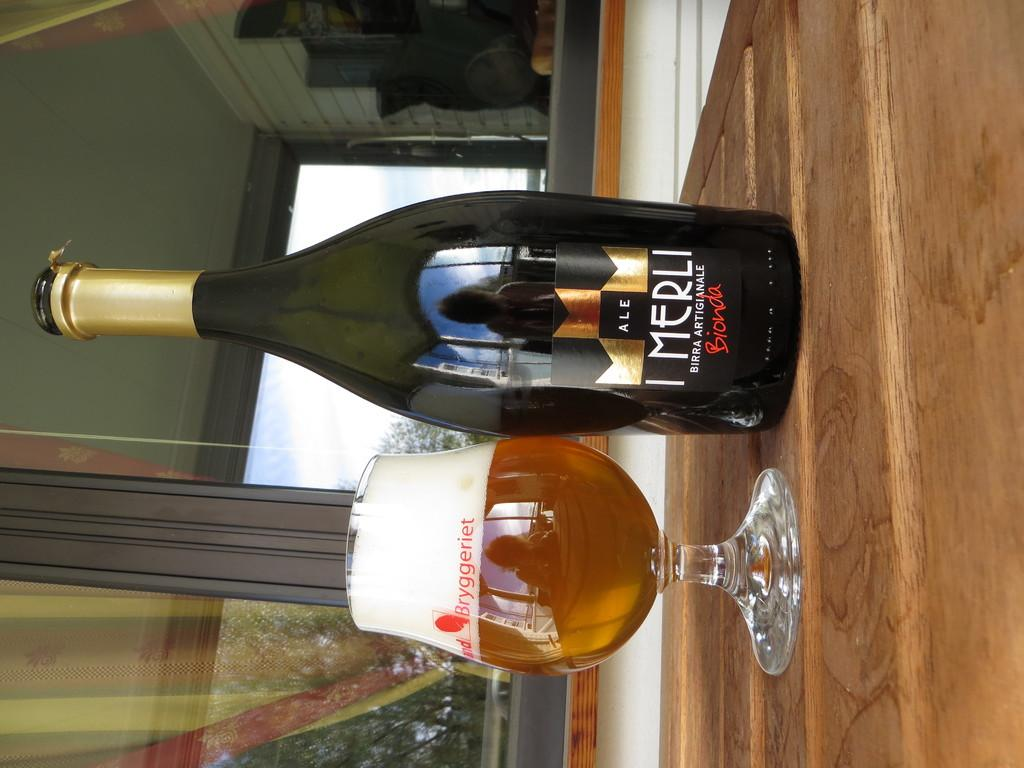<image>
Provide a brief description of the given image. A full Bryggeriet snifter sitting next to a bottle of I Merli Bionda ale. 